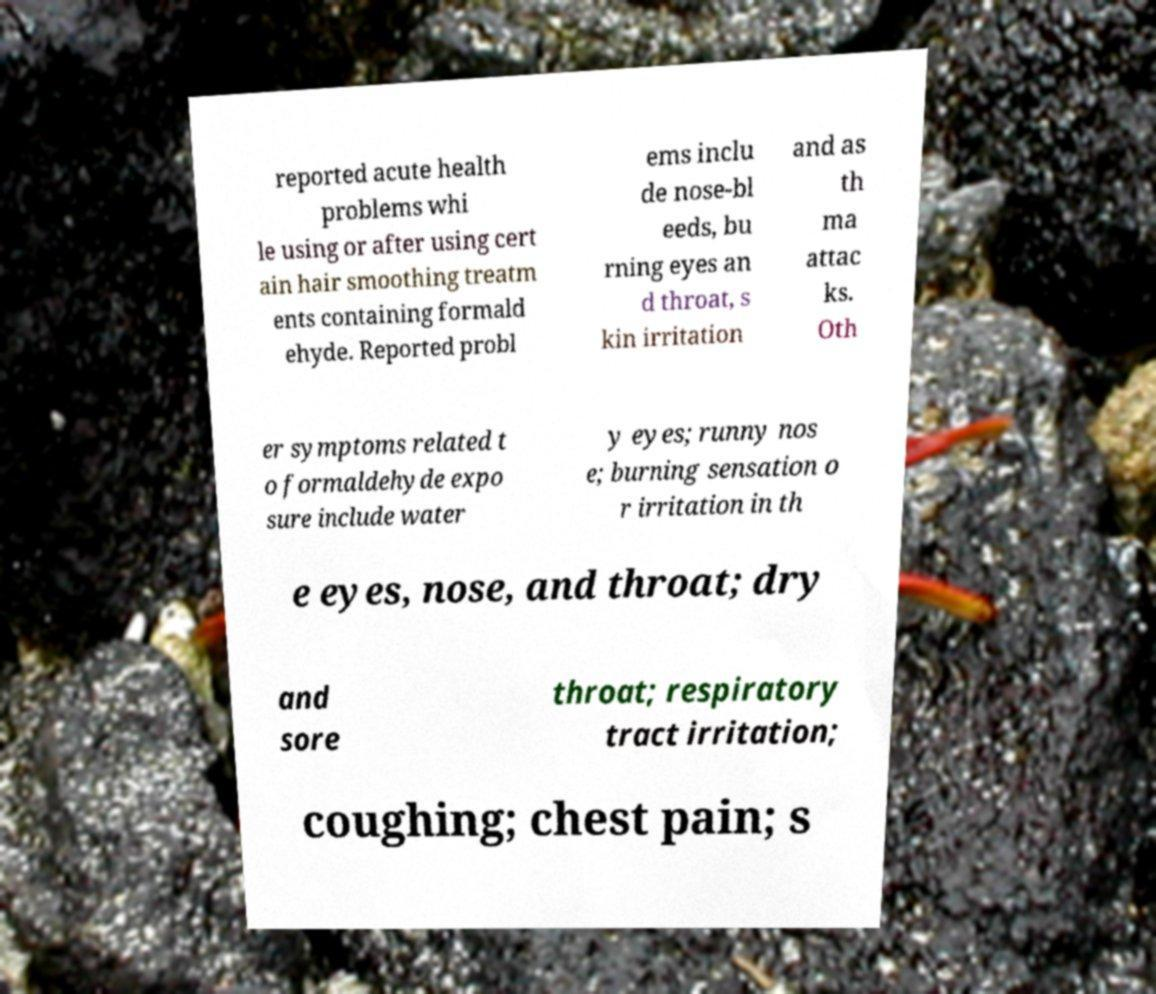For documentation purposes, I need the text within this image transcribed. Could you provide that? reported acute health problems whi le using or after using cert ain hair smoothing treatm ents containing formald ehyde. Reported probl ems inclu de nose-bl eeds, bu rning eyes an d throat, s kin irritation and as th ma attac ks. Oth er symptoms related t o formaldehyde expo sure include water y eyes; runny nos e; burning sensation o r irritation in th e eyes, nose, and throat; dry and sore throat; respiratory tract irritation; coughing; chest pain; s 